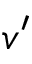<formula> <loc_0><loc_0><loc_500><loc_500>v ^ { \prime }</formula> 